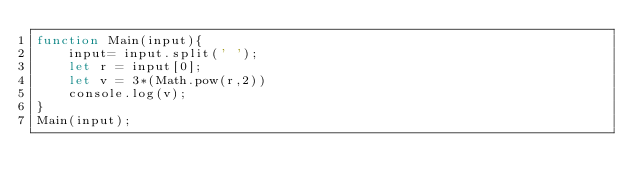<code> <loc_0><loc_0><loc_500><loc_500><_JavaScript_>function Main(input){
    input= input.split(' ');
    let r = input[0];
    let v = 3*(Math.pow(r,2))
    console.log(v);  
}
Main(input);</code> 